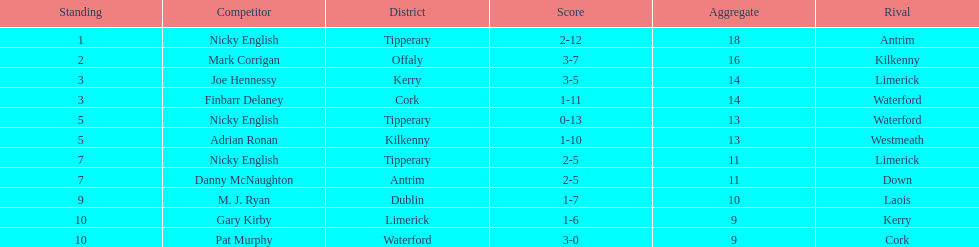What player got 10 total points in their game? M. J. Ryan. 